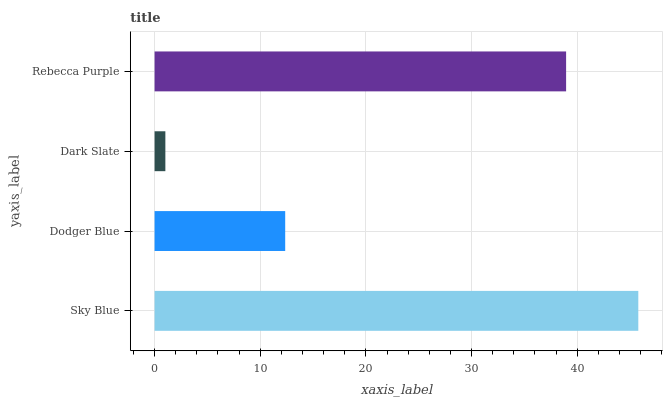Is Dark Slate the minimum?
Answer yes or no. Yes. Is Sky Blue the maximum?
Answer yes or no. Yes. Is Dodger Blue the minimum?
Answer yes or no. No. Is Dodger Blue the maximum?
Answer yes or no. No. Is Sky Blue greater than Dodger Blue?
Answer yes or no. Yes. Is Dodger Blue less than Sky Blue?
Answer yes or no. Yes. Is Dodger Blue greater than Sky Blue?
Answer yes or no. No. Is Sky Blue less than Dodger Blue?
Answer yes or no. No. Is Rebecca Purple the high median?
Answer yes or no. Yes. Is Dodger Blue the low median?
Answer yes or no. Yes. Is Dodger Blue the high median?
Answer yes or no. No. Is Sky Blue the low median?
Answer yes or no. No. 